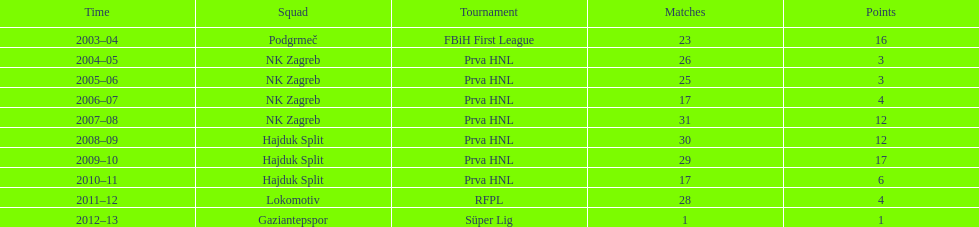What is the highest number of goals scored by senijad ibri&#269;i&#263; in a season? 35. 